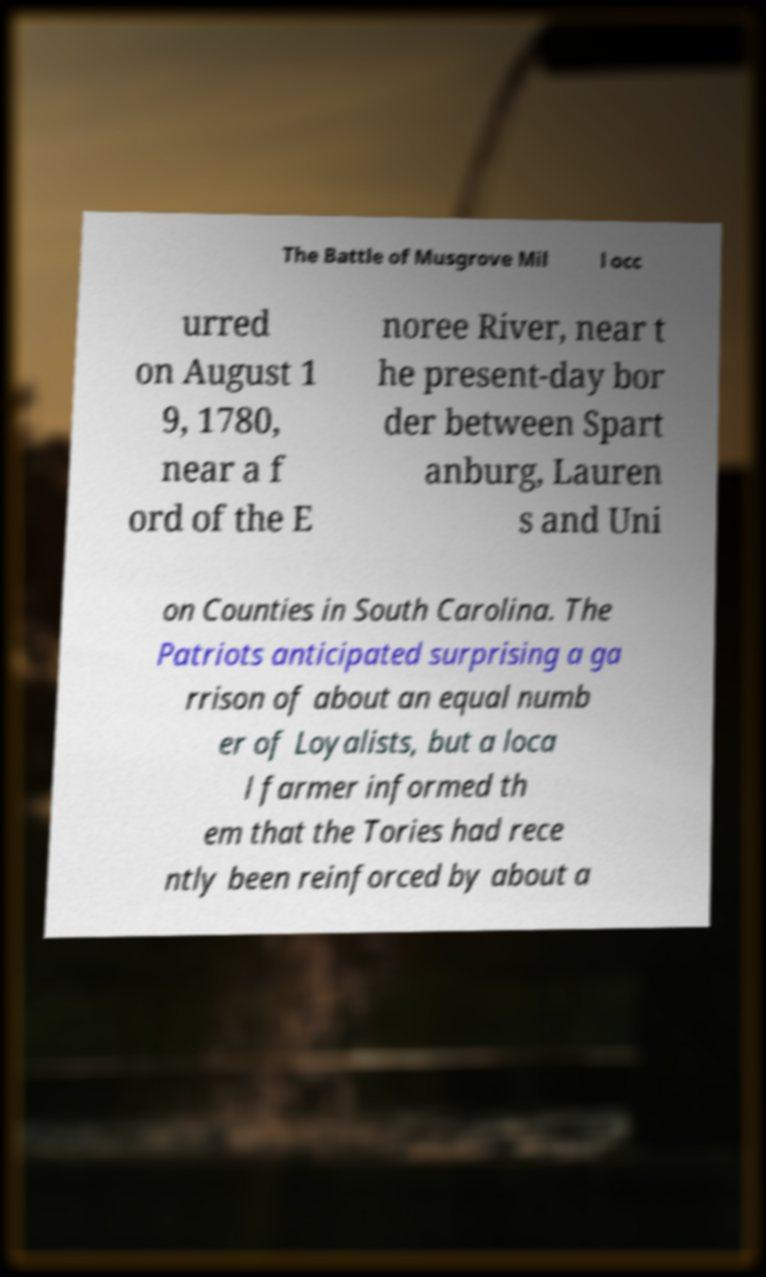There's text embedded in this image that I need extracted. Can you transcribe it verbatim? The Battle of Musgrove Mil l occ urred on August 1 9, 1780, near a f ord of the E noree River, near t he present-day bor der between Spart anburg, Lauren s and Uni on Counties in South Carolina. The Patriots anticipated surprising a ga rrison of about an equal numb er of Loyalists, but a loca l farmer informed th em that the Tories had rece ntly been reinforced by about a 